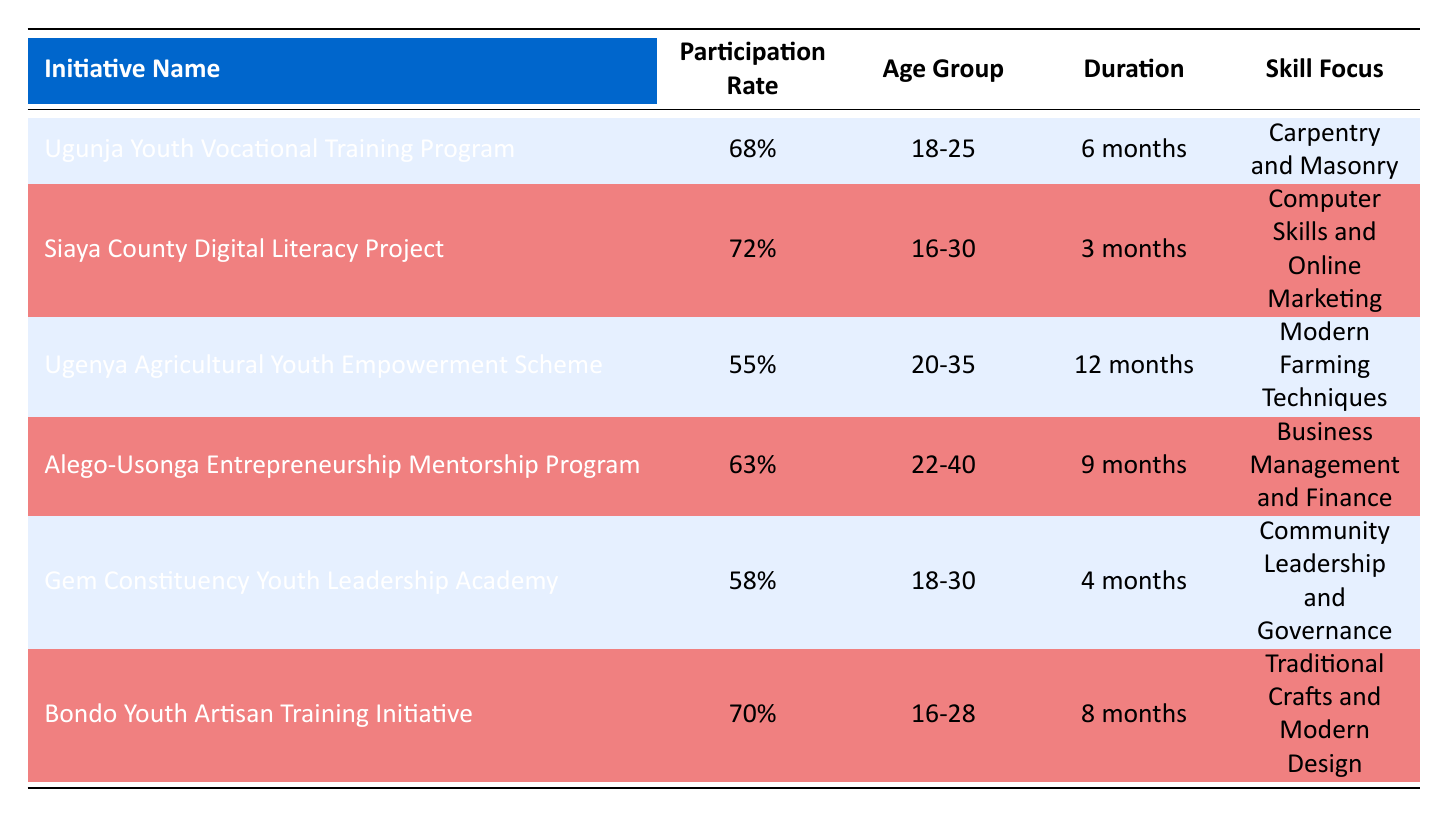What is the participation rate of the Siaya County Digital Literacy Project? The table lists the participation rate of the Siaya County Digital Literacy Project as 72%.
Answer: 72% Which initiative has the highest participation rate? By comparing the participation rates of each initiative, the Siaya County Digital Literacy Project has the highest rate at 72%.
Answer: Siaya County Digital Literacy Project Is the Ugenya Agricultural Youth Empowerment Scheme aimed at a younger age group compared to the Bondo Youth Artisan Training Initiative? The Ugenya Agricultural Youth Empowerment Scheme targets ages 20-35, while the Bondo Youth Artisan Training Initiative targets ages 16-28. Since 16-28 includes younger participants than 20-35, the answer is yes.
Answer: Yes What is the average participation rate of the initiatives focused on vocational skills (Carpentry and Masonry, Computer Skills and Online Marketing, Traditional Crafts and Modern Design)? The initiatives related to vocational skills have the following participation rates: 68%, 72%, and 70%. The sum of these rates is 68 + 72 + 70 = 210, and there are 3 initiatives, so the average is 210/3 = 70%.
Answer: 70% Are there any initiatives with a participation rate below 60%? The Ugenya Agricultural Youth Empowerment Scheme has a participation rate of 55%, which is below 60%. Therefore, the answer is yes.
Answer: Yes Which initiative has the longest duration? The Ugenya Agricultural Youth Empowerment Scheme has the longest duration, listed as 12 months, compared to other initiatives.
Answer: Ugenya Agricultural Youth Empowerment Scheme What is the difference in participation rates between the Bondo Youth Artisan Training Initiative and the Gem Constituency Youth Leadership Academy? The participation rate for Bondo Youth Artisan Training Initiative is 70% and for Gem Constituency Youth Leadership Academy is 58%. The difference is 70 - 58 = 12%.
Answer: 12% Which initiative focuses on community leadership and governance? The initiative that focuses on community leadership and governance is the Gem Constituency Youth Leadership Academy.
Answer: Gem Constituency Youth Leadership Academy 